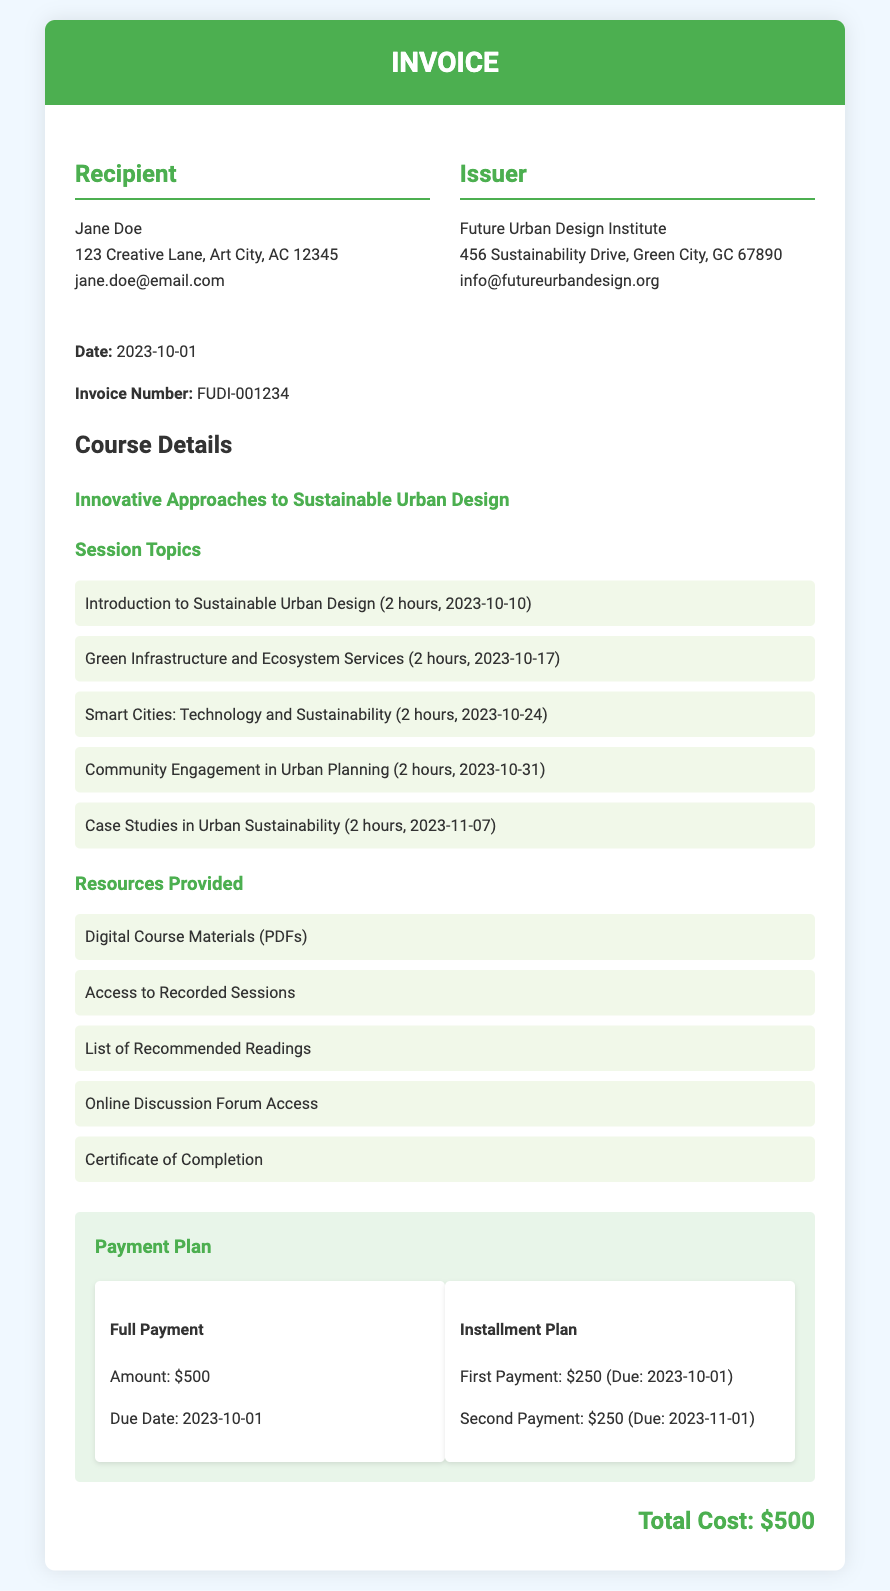What is the title of the course? The title of the course is provided in the course details section of the document.
Answer: Innovative Approaches to Sustainable Urban Design What is the due date for the full payment? The due date for the full payment is specified in the payment plan section.
Answer: 2023-10-01 How many hours is the session on Community Engagement in Urban Planning? The duration of each session is mentioned in the session topics list.
Answer: 2 hours What are the first and second installment amounts? The amounts for the installments are listed under the payment plan section.
Answer: $250 Who is the recipient of the invoice? The recipient information is located in the invoice details at the top of the document.
Answer: Jane Doe What is included in the resources provided section? The resources provided are listed in the course details, showing what students will get in the course.
Answer: Digital Course Materials (PDFs) What is the invoice number? The invoice number is clearly stated in the invoice details section of the document.
Answer: FUDI-001234 How many session topics are covered in the course? The number of session topics can be counted from the list provided in the course details.
Answer: 5 What is the total cost of the course? The total cost is presented at the bottom of the invoice and indicates the complete fee for the course.
Answer: $500 